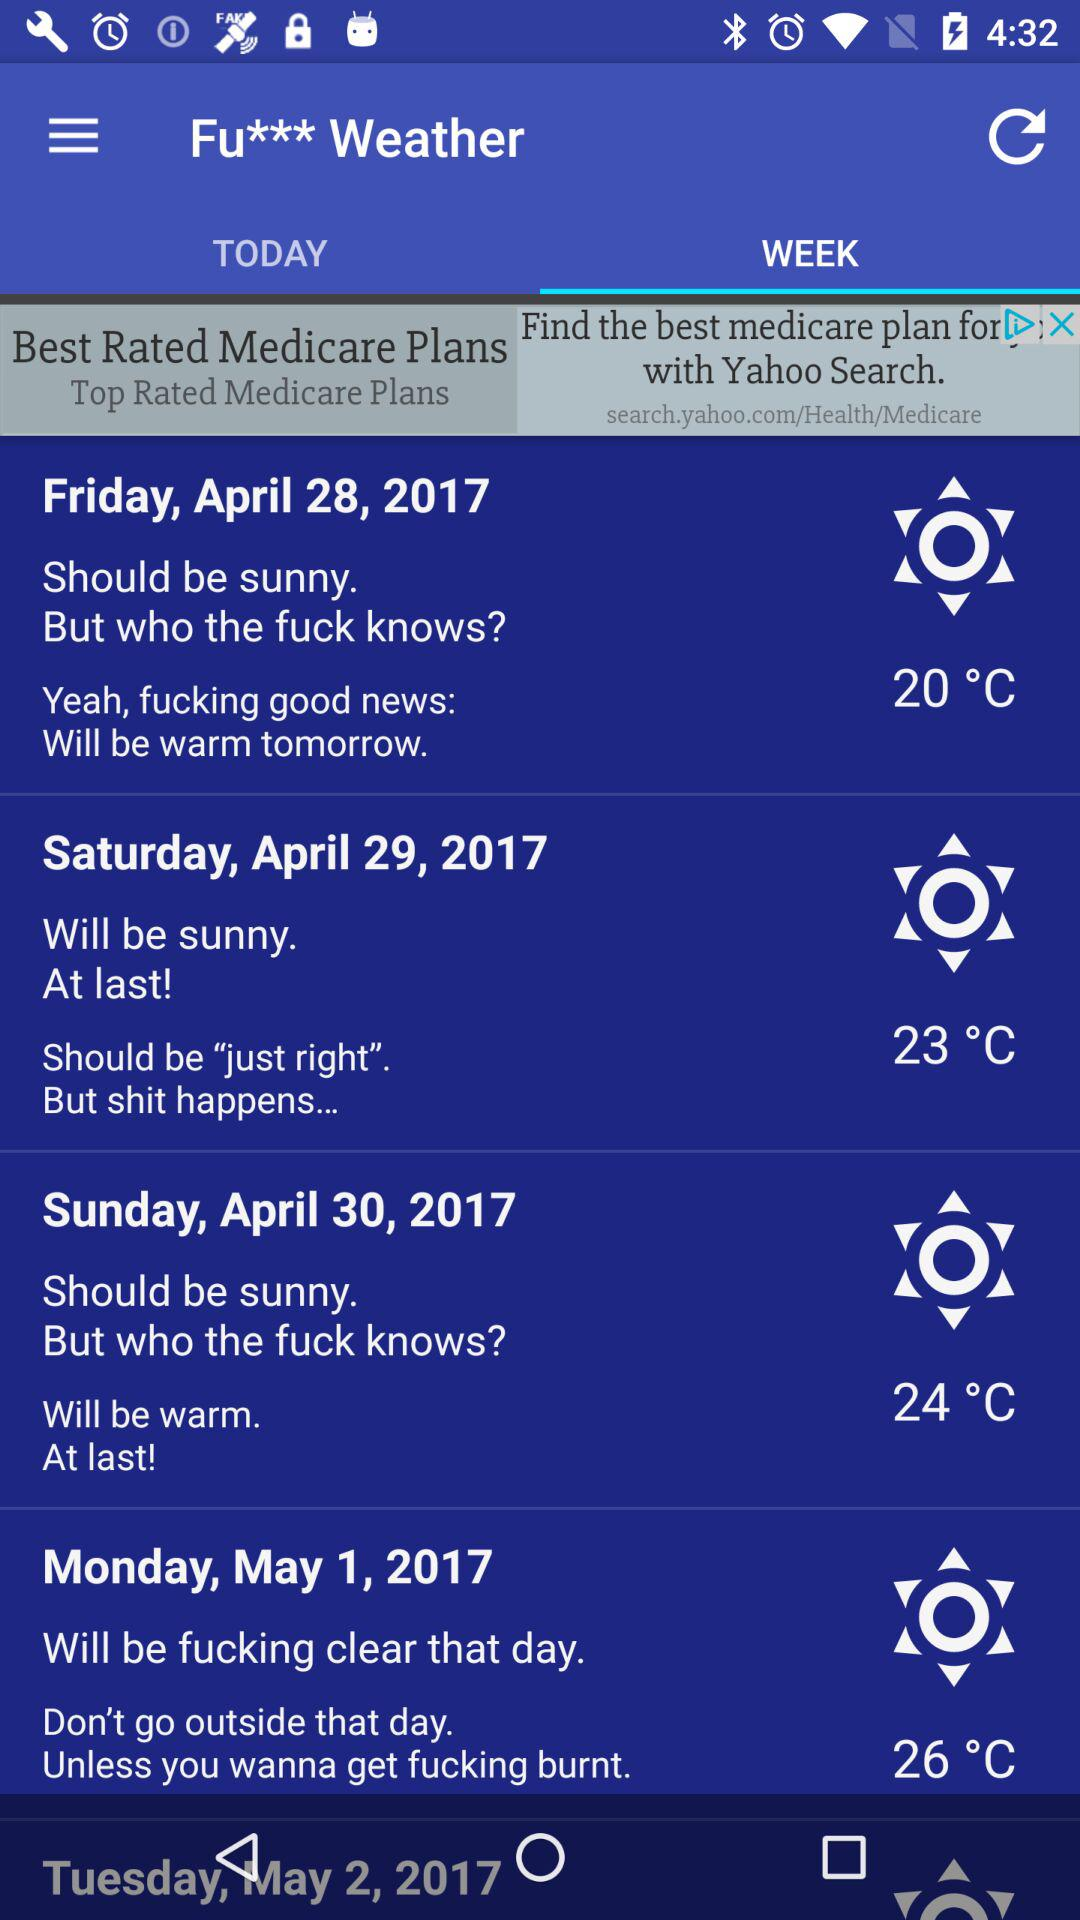What is the weather condition on April 30, 2017? The weather condition is sunny on April 30, 2017. 